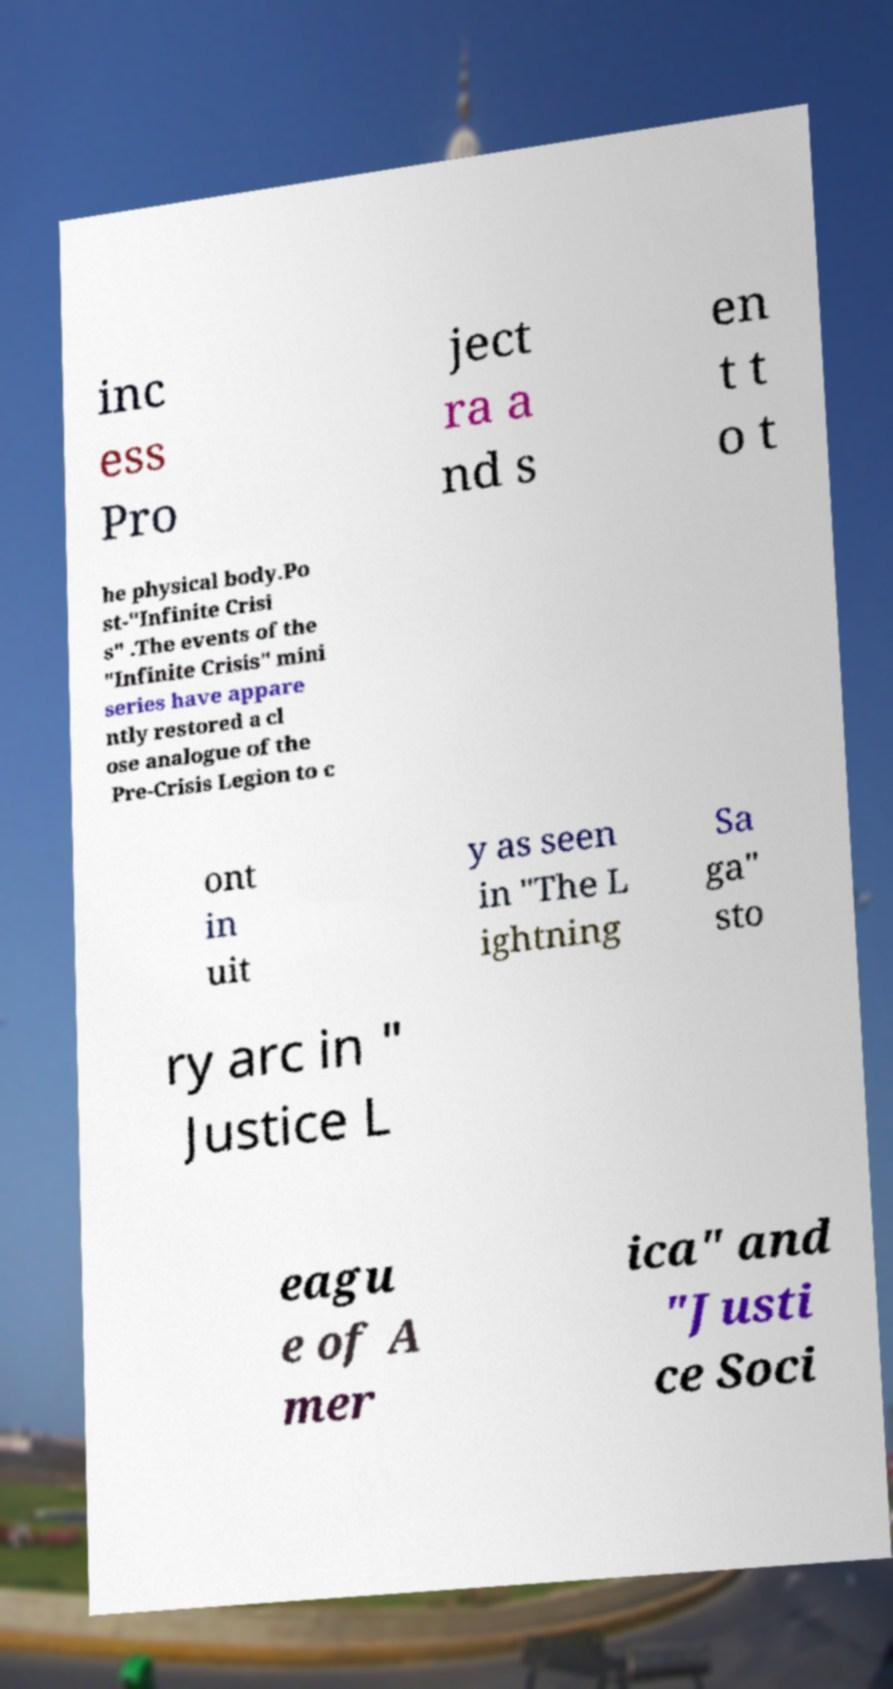What messages or text are displayed in this image? I need them in a readable, typed format. inc ess Pro ject ra a nd s en t t o t he physical body.Po st-"Infinite Crisi s" .The events of the "Infinite Crisis" mini series have appare ntly restored a cl ose analogue of the Pre-Crisis Legion to c ont in uit y as seen in "The L ightning Sa ga" sto ry arc in " Justice L eagu e of A mer ica" and "Justi ce Soci 